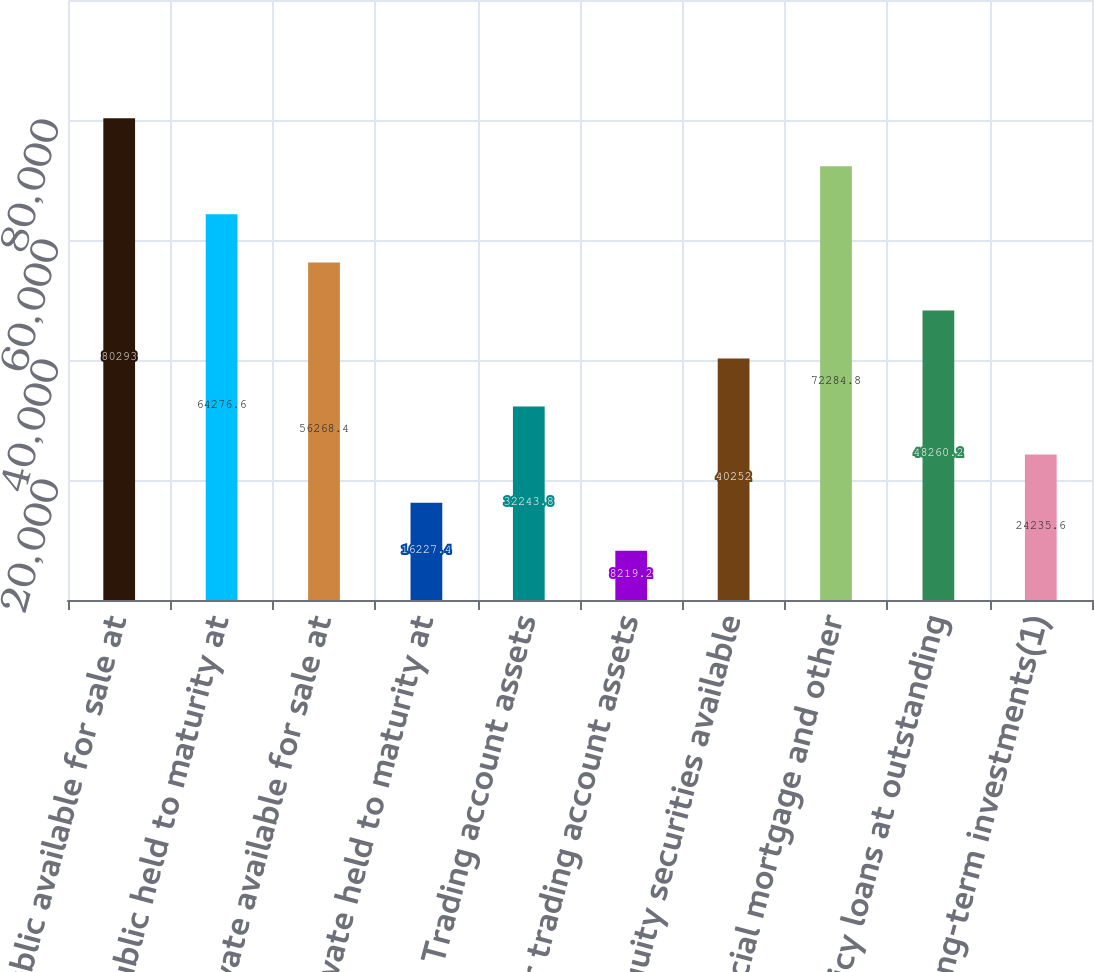Convert chart. <chart><loc_0><loc_0><loc_500><loc_500><bar_chart><fcel>Public available for sale at<fcel>Public held to maturity at<fcel>Private available for sale at<fcel>Private held to maturity at<fcel>Trading account assets<fcel>Other trading account assets<fcel>Equity securities available<fcel>Commercial mortgage and other<fcel>Policy loans at outstanding<fcel>Other long-term investments(1)<nl><fcel>80293<fcel>64276.6<fcel>56268.4<fcel>16227.4<fcel>32243.8<fcel>8219.2<fcel>40252<fcel>72284.8<fcel>48260.2<fcel>24235.6<nl></chart> 